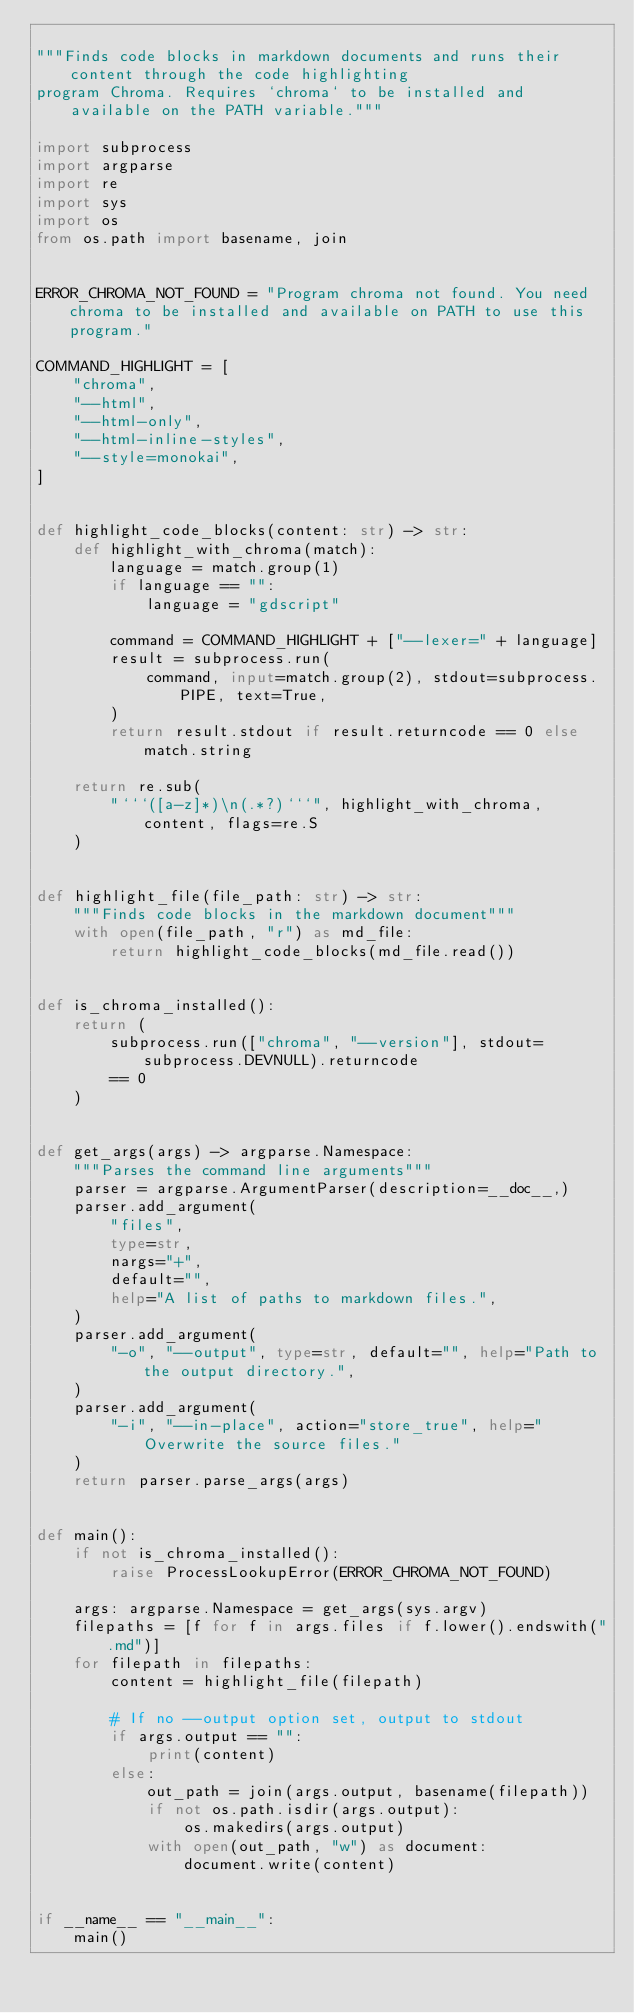Convert code to text. <code><loc_0><loc_0><loc_500><loc_500><_Python_>
"""Finds code blocks in markdown documents and runs their content through the code highlighting
program Chroma. Requires `chroma` to be installed and available on the PATH variable."""

import subprocess
import argparse
import re
import sys
import os
from os.path import basename, join


ERROR_CHROMA_NOT_FOUND = "Program chroma not found. You need chroma to be installed and available on PATH to use this program."

COMMAND_HIGHLIGHT = [
    "chroma",
    "--html",
    "--html-only",
    "--html-inline-styles",
    "--style=monokai",
]


def highlight_code_blocks(content: str) -> str:
    def highlight_with_chroma(match):
        language = match.group(1)
        if language == "":
            language = "gdscript"

        command = COMMAND_HIGHLIGHT + ["--lexer=" + language]
        result = subprocess.run(
            command, input=match.group(2), stdout=subprocess.PIPE, text=True,
        )
        return result.stdout if result.returncode == 0 else match.string

    return re.sub(
        "```([a-z]*)\n(.*?)```", highlight_with_chroma, content, flags=re.S
    )


def highlight_file(file_path: str) -> str:
    """Finds code blocks in the markdown document"""
    with open(file_path, "r") as md_file:
        return highlight_code_blocks(md_file.read())


def is_chroma_installed():
    return (
        subprocess.run(["chroma", "--version"], stdout=subprocess.DEVNULL).returncode
        == 0
    )


def get_args(args) -> argparse.Namespace:
    """Parses the command line arguments"""
    parser = argparse.ArgumentParser(description=__doc__,)
    parser.add_argument(
        "files",
        type=str,
        nargs="+",
        default="",
        help="A list of paths to markdown files.",
    )
    parser.add_argument(
        "-o", "--output", type=str, default="", help="Path to the output directory.",
    )
    parser.add_argument(
        "-i", "--in-place", action="store_true", help="Overwrite the source files."
    )
    return parser.parse_args(args)


def main():
    if not is_chroma_installed():
        raise ProcessLookupError(ERROR_CHROMA_NOT_FOUND)

    args: argparse.Namespace = get_args(sys.argv)
    filepaths = [f for f in args.files if f.lower().endswith(".md")]
    for filepath in filepaths:
        content = highlight_file(filepath)

        # If no --output option set, output to stdout
        if args.output == "":
            print(content)
        else:
            out_path = join(args.output, basename(filepath))
            if not os.path.isdir(args.output):
                os.makedirs(args.output)
            with open(out_path, "w") as document:
                document.write(content)


if __name__ == "__main__":
    main()
</code> 